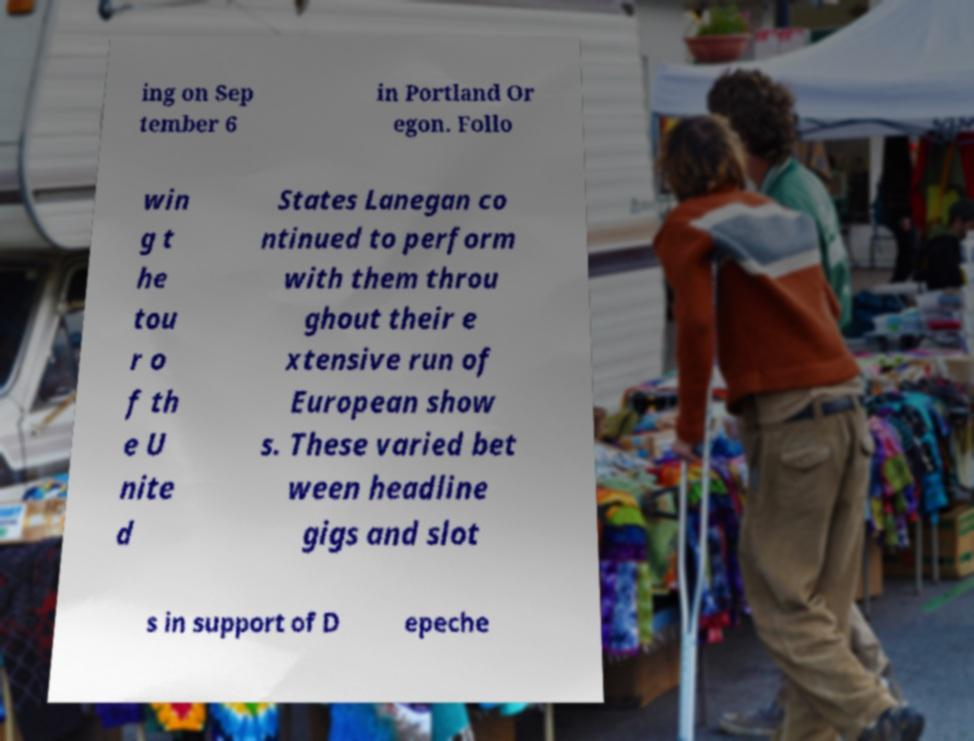I need the written content from this picture converted into text. Can you do that? ing on Sep tember 6 in Portland Or egon. Follo win g t he tou r o f th e U nite d States Lanegan co ntinued to perform with them throu ghout their e xtensive run of European show s. These varied bet ween headline gigs and slot s in support of D epeche 